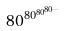Convert formula to latex. <formula><loc_0><loc_0><loc_500><loc_500>8 0 ^ { 8 0 ^ { 8 0 ^ { 8 0 ^ { \dots } } } }</formula> 